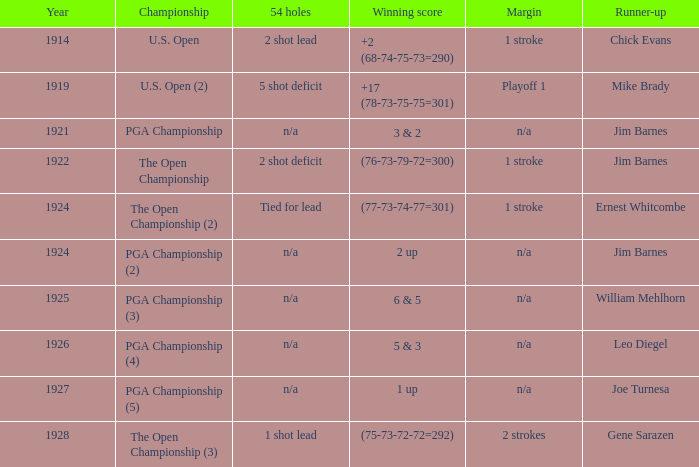In which year did the score reach 3 and 2? 1921.0. 